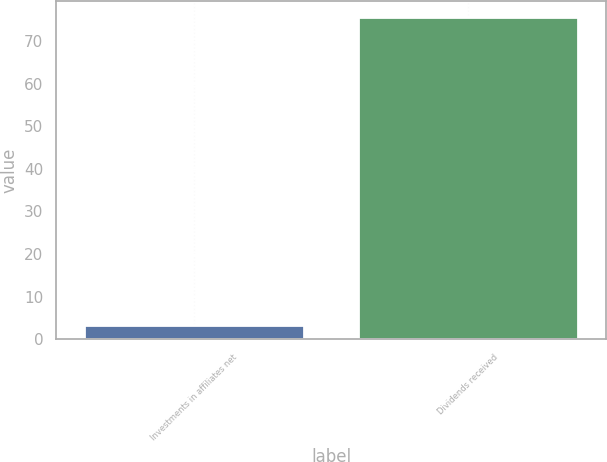Convert chart to OTSL. <chart><loc_0><loc_0><loc_500><loc_500><bar_chart><fcel>Investments in affiliates net<fcel>Dividends received<nl><fcel>3.3<fcel>75.6<nl></chart> 